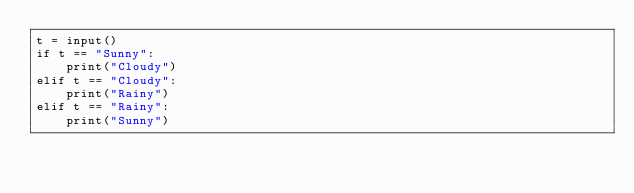Convert code to text. <code><loc_0><loc_0><loc_500><loc_500><_Python_>t = input()
if t == "Sunny":
    print("Cloudy")
elif t == "Cloudy":
    print("Rainy")
elif t == "Rainy":
    print("Sunny")</code> 